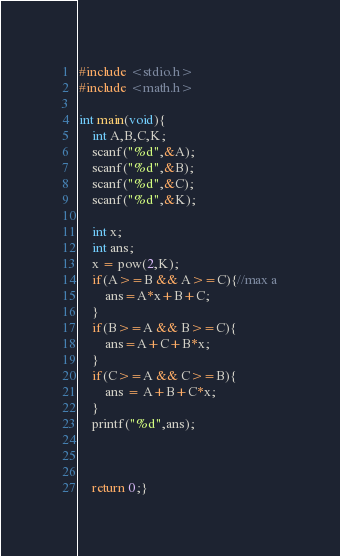Convert code to text. <code><loc_0><loc_0><loc_500><loc_500><_C_>#include <stdio.h>
#include <math.h>

int main(void){
	int A,B,C,K;
	scanf("%d",&A);
	scanf("%d",&B);
	scanf("%d",&C);
	scanf("%d",&K);
	
	int x;
	int ans;
	x = pow(2,K);
	if(A>=B && A>=C){//max a
		ans=A*x+B+C;
	}
	if(B>=A && B>=C){
		ans=A+C+B*x;
	}
	if(C>=A && C>=B){
		ans = A+B+C*x;
	}
	printf("%d",ans);
	
	
	
	return 0;}</code> 